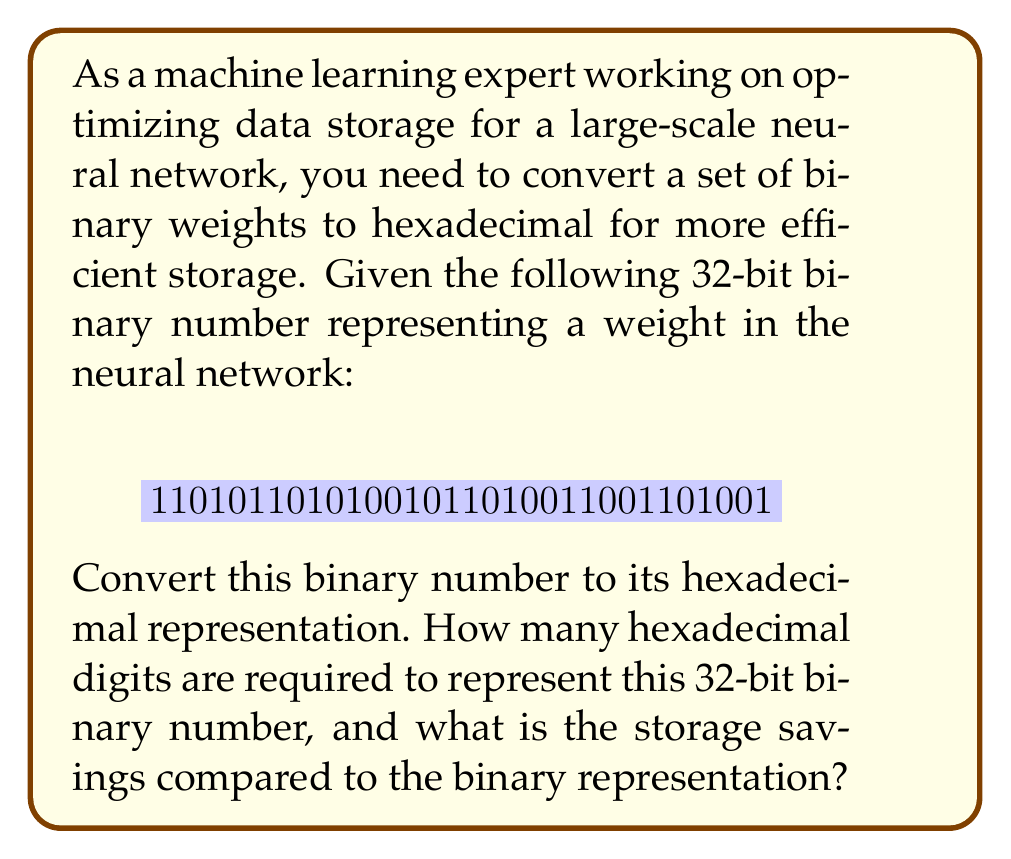Give your solution to this math problem. To convert a binary number to hexadecimal, we can follow these steps:

1. Group the binary digits into sets of 4, starting from the right:
   $$ 1101 \  0110 \  1010 \  0101 \  1010 \  0110 \  0110 \  1001 $$

2. Convert each group of 4 binary digits to its hexadecimal equivalent:

   $1101 = 13 = \text{D}$
   $0110 = 6$
   $1010 = 10 = \text{A}$
   $0101 = 5$
   $1010 = 10 = \text{A}$
   $0110 = 6$
   $0110 = 6$
   $1001 = 9$

3. Combine the hexadecimal digits:
   $$ \text{D6A5A669} $$

The hexadecimal representation requires 8 digits to represent the 32-bit binary number.

To calculate the storage savings:
- Binary representation: 32 bits
- Hexadecimal representation: 8 digits * 4 bits/digit = 32 bits

The storage requirement is the same in this case, but hexadecimal is more compact for human readability and easier to manipulate in many programming contexts. In practice, when dealing with large amounts of data, hexadecimal representation can lead to more efficient data handling and processing in machine learning applications.
Answer: The 32-bit binary number converts to the hexadecimal representation $\text{D6A5A669}$. It requires 8 hexadecimal digits. There is no direct storage savings in bits, but the hexadecimal representation is more compact for human readability and can lead to more efficient data handling in machine learning applications. 